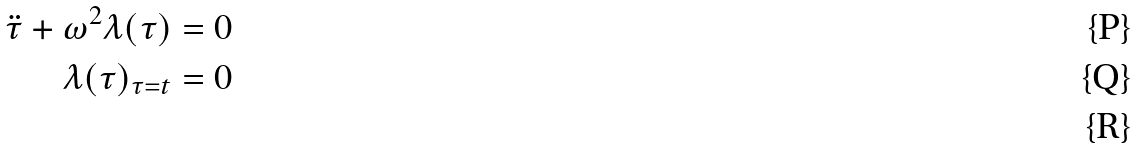Convert formula to latex. <formula><loc_0><loc_0><loc_500><loc_500>\ddot { \tau } + { \omega } ^ { 2 } { \lambda } ( \tau ) = 0 \\ \lambda ( \tau ) _ { \tau = t } = 0 \\</formula> 